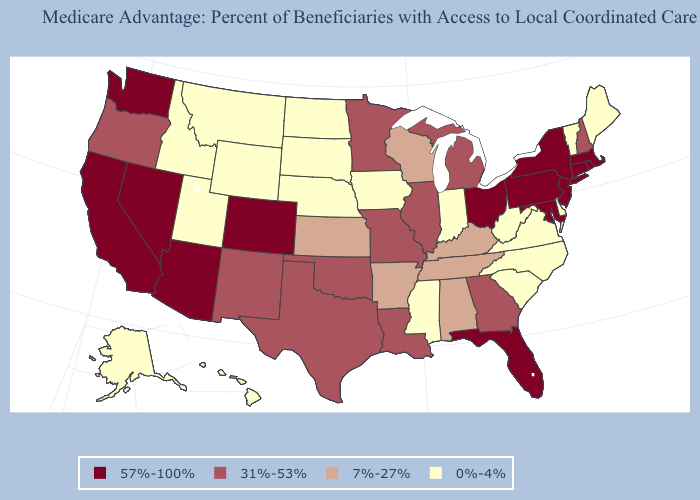What is the highest value in states that border Arizona?
Write a very short answer. 57%-100%. Name the states that have a value in the range 31%-53%?
Concise answer only. Georgia, Illinois, Louisiana, Michigan, Minnesota, Missouri, New Hampshire, New Mexico, Oklahoma, Oregon, Texas. Which states have the lowest value in the USA?
Answer briefly. Alaska, Delaware, Hawaii, Iowa, Idaho, Indiana, Maine, Mississippi, Montana, North Carolina, North Dakota, Nebraska, South Carolina, South Dakota, Utah, Virginia, Vermont, West Virginia, Wyoming. Name the states that have a value in the range 7%-27%?
Concise answer only. Alabama, Arkansas, Kansas, Kentucky, Tennessee, Wisconsin. Which states have the lowest value in the South?
Quick response, please. Delaware, Mississippi, North Carolina, South Carolina, Virginia, West Virginia. Does the map have missing data?
Be succinct. No. Does the first symbol in the legend represent the smallest category?
Write a very short answer. No. What is the value of California?
Concise answer only. 57%-100%. What is the highest value in states that border Idaho?
Concise answer only. 57%-100%. Name the states that have a value in the range 7%-27%?
Keep it brief. Alabama, Arkansas, Kansas, Kentucky, Tennessee, Wisconsin. What is the value of Wisconsin?
Quick response, please. 7%-27%. What is the value of Washington?
Give a very brief answer. 57%-100%. What is the value of Minnesota?
Be succinct. 31%-53%. What is the value of Washington?
Answer briefly. 57%-100%. Among the states that border Wisconsin , does Iowa have the highest value?
Be succinct. No. 